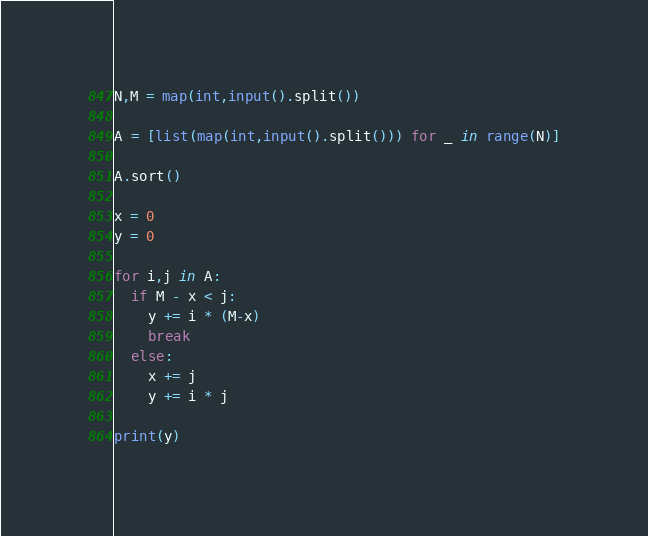<code> <loc_0><loc_0><loc_500><loc_500><_Python_>N,M = map(int,input().split())

A = [list(map(int,input().split())) for _ in range(N)]

A.sort()

x = 0
y = 0

for i,j in A:
  if M - x < j:
    y += i * (M-x)
    break    
  else:
    x += j
    y += i * j

print(y)    
</code> 